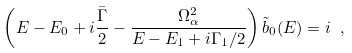Convert formula to latex. <formula><loc_0><loc_0><loc_500><loc_500>\left ( E - E _ { 0 } + i \frac { \bar { \Gamma } } { 2 } - \frac { \Omega _ { \alpha } ^ { 2 } } { E - E _ { 1 } + i \Gamma _ { 1 } / 2 } \right ) \tilde { b } _ { 0 } ( E ) = i \ ,</formula> 